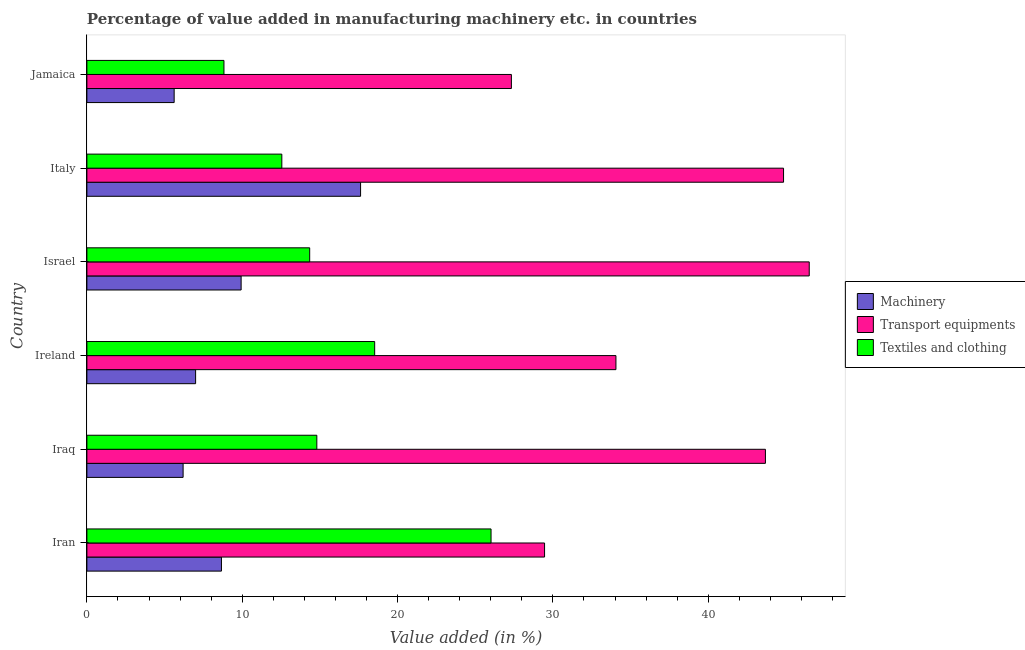How many different coloured bars are there?
Keep it short and to the point. 3. How many groups of bars are there?
Make the answer very short. 6. Are the number of bars on each tick of the Y-axis equal?
Your answer should be very brief. Yes. How many bars are there on the 1st tick from the top?
Your answer should be compact. 3. How many bars are there on the 6th tick from the bottom?
Offer a very short reply. 3. What is the label of the 4th group of bars from the top?
Your answer should be very brief. Ireland. What is the value added in manufacturing transport equipments in Ireland?
Keep it short and to the point. 34.06. Across all countries, what is the maximum value added in manufacturing transport equipments?
Keep it short and to the point. 46.5. Across all countries, what is the minimum value added in manufacturing machinery?
Give a very brief answer. 5.62. In which country was the value added in manufacturing transport equipments maximum?
Offer a terse response. Israel. In which country was the value added in manufacturing textile and clothing minimum?
Keep it short and to the point. Jamaica. What is the total value added in manufacturing transport equipments in the graph?
Your answer should be very brief. 225.88. What is the difference between the value added in manufacturing textile and clothing in Iraq and that in Ireland?
Provide a succinct answer. -3.72. What is the difference between the value added in manufacturing textile and clothing in Iran and the value added in manufacturing machinery in Ireland?
Ensure brevity in your answer.  19.02. What is the average value added in manufacturing machinery per country?
Offer a very short reply. 9.17. What is the difference between the value added in manufacturing transport equipments and value added in manufacturing machinery in Israel?
Give a very brief answer. 36.57. What is the ratio of the value added in manufacturing machinery in Iran to that in Italy?
Your answer should be compact. 0.49. Is the value added in manufacturing transport equipments in Ireland less than that in Jamaica?
Provide a short and direct response. No. Is the difference between the value added in manufacturing machinery in Iran and Italy greater than the difference between the value added in manufacturing transport equipments in Iran and Italy?
Provide a short and direct response. Yes. What is the difference between the highest and the second highest value added in manufacturing textile and clothing?
Ensure brevity in your answer.  7.49. What is the difference between the highest and the lowest value added in manufacturing transport equipments?
Ensure brevity in your answer.  19.17. What does the 1st bar from the top in Jamaica represents?
Ensure brevity in your answer.  Textiles and clothing. What does the 2nd bar from the bottom in Iran represents?
Your answer should be compact. Transport equipments. Are all the bars in the graph horizontal?
Your answer should be compact. Yes. How many countries are there in the graph?
Ensure brevity in your answer.  6. What is the difference between two consecutive major ticks on the X-axis?
Offer a terse response. 10. Are the values on the major ticks of X-axis written in scientific E-notation?
Your answer should be very brief. No. Does the graph contain any zero values?
Make the answer very short. No. Where does the legend appear in the graph?
Your response must be concise. Center right. What is the title of the graph?
Keep it short and to the point. Percentage of value added in manufacturing machinery etc. in countries. What is the label or title of the X-axis?
Offer a terse response. Value added (in %). What is the Value added (in %) of Machinery in Iran?
Provide a short and direct response. 8.66. What is the Value added (in %) of Transport equipments in Iran?
Make the answer very short. 29.46. What is the Value added (in %) in Textiles and clothing in Iran?
Ensure brevity in your answer.  26.02. What is the Value added (in %) in Machinery in Iraq?
Give a very brief answer. 6.19. What is the Value added (in %) in Transport equipments in Iraq?
Provide a succinct answer. 43.68. What is the Value added (in %) in Textiles and clothing in Iraq?
Offer a very short reply. 14.8. What is the Value added (in %) in Machinery in Ireland?
Offer a very short reply. 7. What is the Value added (in %) of Transport equipments in Ireland?
Your answer should be very brief. 34.06. What is the Value added (in %) in Textiles and clothing in Ireland?
Make the answer very short. 18.53. What is the Value added (in %) of Machinery in Israel?
Offer a very short reply. 9.93. What is the Value added (in %) in Transport equipments in Israel?
Offer a very short reply. 46.5. What is the Value added (in %) of Textiles and clothing in Israel?
Provide a succinct answer. 14.34. What is the Value added (in %) in Machinery in Italy?
Give a very brief answer. 17.62. What is the Value added (in %) of Transport equipments in Italy?
Your response must be concise. 44.85. What is the Value added (in %) in Textiles and clothing in Italy?
Make the answer very short. 12.55. What is the Value added (in %) in Machinery in Jamaica?
Keep it short and to the point. 5.62. What is the Value added (in %) in Transport equipments in Jamaica?
Keep it short and to the point. 27.33. What is the Value added (in %) in Textiles and clothing in Jamaica?
Your response must be concise. 8.82. Across all countries, what is the maximum Value added (in %) of Machinery?
Offer a terse response. 17.62. Across all countries, what is the maximum Value added (in %) in Transport equipments?
Offer a very short reply. 46.5. Across all countries, what is the maximum Value added (in %) in Textiles and clothing?
Give a very brief answer. 26.02. Across all countries, what is the minimum Value added (in %) of Machinery?
Your response must be concise. 5.62. Across all countries, what is the minimum Value added (in %) in Transport equipments?
Your answer should be compact. 27.33. Across all countries, what is the minimum Value added (in %) in Textiles and clothing?
Offer a terse response. 8.82. What is the total Value added (in %) in Machinery in the graph?
Provide a short and direct response. 55.02. What is the total Value added (in %) of Transport equipments in the graph?
Offer a very short reply. 225.88. What is the total Value added (in %) of Textiles and clothing in the graph?
Your answer should be compact. 95.06. What is the difference between the Value added (in %) in Machinery in Iran and that in Iraq?
Provide a succinct answer. 2.47. What is the difference between the Value added (in %) of Transport equipments in Iran and that in Iraq?
Offer a terse response. -14.22. What is the difference between the Value added (in %) of Textiles and clothing in Iran and that in Iraq?
Offer a very short reply. 11.22. What is the difference between the Value added (in %) in Machinery in Iran and that in Ireland?
Provide a short and direct response. 1.66. What is the difference between the Value added (in %) of Transport equipments in Iran and that in Ireland?
Give a very brief answer. -4.59. What is the difference between the Value added (in %) of Textiles and clothing in Iran and that in Ireland?
Give a very brief answer. 7.49. What is the difference between the Value added (in %) of Machinery in Iran and that in Israel?
Ensure brevity in your answer.  -1.27. What is the difference between the Value added (in %) of Transport equipments in Iran and that in Israel?
Your response must be concise. -17.04. What is the difference between the Value added (in %) of Textiles and clothing in Iran and that in Israel?
Your response must be concise. 11.68. What is the difference between the Value added (in %) in Machinery in Iran and that in Italy?
Make the answer very short. -8.96. What is the difference between the Value added (in %) of Transport equipments in Iran and that in Italy?
Your response must be concise. -15.38. What is the difference between the Value added (in %) of Textiles and clothing in Iran and that in Italy?
Ensure brevity in your answer.  13.47. What is the difference between the Value added (in %) of Machinery in Iran and that in Jamaica?
Provide a succinct answer. 3.04. What is the difference between the Value added (in %) in Transport equipments in Iran and that in Jamaica?
Your answer should be compact. 2.14. What is the difference between the Value added (in %) of Textiles and clothing in Iran and that in Jamaica?
Offer a very short reply. 17.19. What is the difference between the Value added (in %) of Machinery in Iraq and that in Ireland?
Your answer should be very brief. -0.8. What is the difference between the Value added (in %) in Transport equipments in Iraq and that in Ireland?
Keep it short and to the point. 9.62. What is the difference between the Value added (in %) of Textiles and clothing in Iraq and that in Ireland?
Offer a terse response. -3.72. What is the difference between the Value added (in %) of Machinery in Iraq and that in Israel?
Your answer should be compact. -3.73. What is the difference between the Value added (in %) of Transport equipments in Iraq and that in Israel?
Your answer should be compact. -2.82. What is the difference between the Value added (in %) of Textiles and clothing in Iraq and that in Israel?
Your response must be concise. 0.46. What is the difference between the Value added (in %) in Machinery in Iraq and that in Italy?
Offer a very short reply. -11.42. What is the difference between the Value added (in %) in Transport equipments in Iraq and that in Italy?
Make the answer very short. -1.17. What is the difference between the Value added (in %) in Textiles and clothing in Iraq and that in Italy?
Your response must be concise. 2.25. What is the difference between the Value added (in %) of Machinery in Iraq and that in Jamaica?
Offer a very short reply. 0.58. What is the difference between the Value added (in %) of Transport equipments in Iraq and that in Jamaica?
Provide a succinct answer. 16.35. What is the difference between the Value added (in %) of Textiles and clothing in Iraq and that in Jamaica?
Your response must be concise. 5.98. What is the difference between the Value added (in %) in Machinery in Ireland and that in Israel?
Your answer should be compact. -2.93. What is the difference between the Value added (in %) in Transport equipments in Ireland and that in Israel?
Give a very brief answer. -12.44. What is the difference between the Value added (in %) of Textiles and clothing in Ireland and that in Israel?
Offer a terse response. 4.18. What is the difference between the Value added (in %) of Machinery in Ireland and that in Italy?
Your response must be concise. -10.62. What is the difference between the Value added (in %) of Transport equipments in Ireland and that in Italy?
Provide a succinct answer. -10.79. What is the difference between the Value added (in %) of Textiles and clothing in Ireland and that in Italy?
Ensure brevity in your answer.  5.98. What is the difference between the Value added (in %) in Machinery in Ireland and that in Jamaica?
Provide a succinct answer. 1.38. What is the difference between the Value added (in %) in Transport equipments in Ireland and that in Jamaica?
Your response must be concise. 6.73. What is the difference between the Value added (in %) in Textiles and clothing in Ireland and that in Jamaica?
Keep it short and to the point. 9.7. What is the difference between the Value added (in %) of Machinery in Israel and that in Italy?
Offer a very short reply. -7.69. What is the difference between the Value added (in %) of Transport equipments in Israel and that in Italy?
Provide a succinct answer. 1.65. What is the difference between the Value added (in %) of Textiles and clothing in Israel and that in Italy?
Your response must be concise. 1.79. What is the difference between the Value added (in %) in Machinery in Israel and that in Jamaica?
Keep it short and to the point. 4.31. What is the difference between the Value added (in %) of Transport equipments in Israel and that in Jamaica?
Provide a short and direct response. 19.17. What is the difference between the Value added (in %) in Textiles and clothing in Israel and that in Jamaica?
Give a very brief answer. 5.52. What is the difference between the Value added (in %) in Machinery in Italy and that in Jamaica?
Offer a very short reply. 12. What is the difference between the Value added (in %) of Transport equipments in Italy and that in Jamaica?
Ensure brevity in your answer.  17.52. What is the difference between the Value added (in %) in Textiles and clothing in Italy and that in Jamaica?
Give a very brief answer. 3.73. What is the difference between the Value added (in %) in Machinery in Iran and the Value added (in %) in Transport equipments in Iraq?
Give a very brief answer. -35.02. What is the difference between the Value added (in %) of Machinery in Iran and the Value added (in %) of Textiles and clothing in Iraq?
Make the answer very short. -6.14. What is the difference between the Value added (in %) of Transport equipments in Iran and the Value added (in %) of Textiles and clothing in Iraq?
Your answer should be compact. 14.66. What is the difference between the Value added (in %) in Machinery in Iran and the Value added (in %) in Transport equipments in Ireland?
Provide a short and direct response. -25.4. What is the difference between the Value added (in %) of Machinery in Iran and the Value added (in %) of Textiles and clothing in Ireland?
Offer a terse response. -9.86. What is the difference between the Value added (in %) in Transport equipments in Iran and the Value added (in %) in Textiles and clothing in Ireland?
Offer a terse response. 10.94. What is the difference between the Value added (in %) of Machinery in Iran and the Value added (in %) of Transport equipments in Israel?
Keep it short and to the point. -37.84. What is the difference between the Value added (in %) in Machinery in Iran and the Value added (in %) in Textiles and clothing in Israel?
Provide a succinct answer. -5.68. What is the difference between the Value added (in %) of Transport equipments in Iran and the Value added (in %) of Textiles and clothing in Israel?
Offer a very short reply. 15.12. What is the difference between the Value added (in %) in Machinery in Iran and the Value added (in %) in Transport equipments in Italy?
Your response must be concise. -36.18. What is the difference between the Value added (in %) of Machinery in Iran and the Value added (in %) of Textiles and clothing in Italy?
Ensure brevity in your answer.  -3.89. What is the difference between the Value added (in %) of Transport equipments in Iran and the Value added (in %) of Textiles and clothing in Italy?
Offer a terse response. 16.91. What is the difference between the Value added (in %) in Machinery in Iran and the Value added (in %) in Transport equipments in Jamaica?
Offer a terse response. -18.66. What is the difference between the Value added (in %) of Machinery in Iran and the Value added (in %) of Textiles and clothing in Jamaica?
Your response must be concise. -0.16. What is the difference between the Value added (in %) of Transport equipments in Iran and the Value added (in %) of Textiles and clothing in Jamaica?
Offer a terse response. 20.64. What is the difference between the Value added (in %) in Machinery in Iraq and the Value added (in %) in Transport equipments in Ireland?
Your answer should be compact. -27.86. What is the difference between the Value added (in %) in Machinery in Iraq and the Value added (in %) in Textiles and clothing in Ireland?
Your answer should be compact. -12.33. What is the difference between the Value added (in %) of Transport equipments in Iraq and the Value added (in %) of Textiles and clothing in Ireland?
Provide a short and direct response. 25.16. What is the difference between the Value added (in %) of Machinery in Iraq and the Value added (in %) of Transport equipments in Israel?
Give a very brief answer. -40.31. What is the difference between the Value added (in %) in Machinery in Iraq and the Value added (in %) in Textiles and clothing in Israel?
Make the answer very short. -8.15. What is the difference between the Value added (in %) of Transport equipments in Iraq and the Value added (in %) of Textiles and clothing in Israel?
Offer a terse response. 29.34. What is the difference between the Value added (in %) in Machinery in Iraq and the Value added (in %) in Transport equipments in Italy?
Offer a very short reply. -38.65. What is the difference between the Value added (in %) of Machinery in Iraq and the Value added (in %) of Textiles and clothing in Italy?
Make the answer very short. -6.36. What is the difference between the Value added (in %) of Transport equipments in Iraq and the Value added (in %) of Textiles and clothing in Italy?
Keep it short and to the point. 31.13. What is the difference between the Value added (in %) of Machinery in Iraq and the Value added (in %) of Transport equipments in Jamaica?
Provide a succinct answer. -21.13. What is the difference between the Value added (in %) in Machinery in Iraq and the Value added (in %) in Textiles and clothing in Jamaica?
Offer a terse response. -2.63. What is the difference between the Value added (in %) of Transport equipments in Iraq and the Value added (in %) of Textiles and clothing in Jamaica?
Ensure brevity in your answer.  34.86. What is the difference between the Value added (in %) in Machinery in Ireland and the Value added (in %) in Transport equipments in Israel?
Your response must be concise. -39.5. What is the difference between the Value added (in %) of Machinery in Ireland and the Value added (in %) of Textiles and clothing in Israel?
Your response must be concise. -7.34. What is the difference between the Value added (in %) of Transport equipments in Ireland and the Value added (in %) of Textiles and clothing in Israel?
Give a very brief answer. 19.72. What is the difference between the Value added (in %) in Machinery in Ireland and the Value added (in %) in Transport equipments in Italy?
Your answer should be very brief. -37.85. What is the difference between the Value added (in %) in Machinery in Ireland and the Value added (in %) in Textiles and clothing in Italy?
Keep it short and to the point. -5.55. What is the difference between the Value added (in %) in Transport equipments in Ireland and the Value added (in %) in Textiles and clothing in Italy?
Offer a terse response. 21.51. What is the difference between the Value added (in %) in Machinery in Ireland and the Value added (in %) in Transport equipments in Jamaica?
Offer a terse response. -20.33. What is the difference between the Value added (in %) of Machinery in Ireland and the Value added (in %) of Textiles and clothing in Jamaica?
Your answer should be compact. -1.83. What is the difference between the Value added (in %) of Transport equipments in Ireland and the Value added (in %) of Textiles and clothing in Jamaica?
Your response must be concise. 25.23. What is the difference between the Value added (in %) of Machinery in Israel and the Value added (in %) of Transport equipments in Italy?
Offer a very short reply. -34.92. What is the difference between the Value added (in %) of Machinery in Israel and the Value added (in %) of Textiles and clothing in Italy?
Your answer should be very brief. -2.62. What is the difference between the Value added (in %) in Transport equipments in Israel and the Value added (in %) in Textiles and clothing in Italy?
Provide a succinct answer. 33.95. What is the difference between the Value added (in %) in Machinery in Israel and the Value added (in %) in Transport equipments in Jamaica?
Offer a terse response. -17.4. What is the difference between the Value added (in %) in Machinery in Israel and the Value added (in %) in Textiles and clothing in Jamaica?
Give a very brief answer. 1.11. What is the difference between the Value added (in %) in Transport equipments in Israel and the Value added (in %) in Textiles and clothing in Jamaica?
Your answer should be compact. 37.68. What is the difference between the Value added (in %) in Machinery in Italy and the Value added (in %) in Transport equipments in Jamaica?
Make the answer very short. -9.71. What is the difference between the Value added (in %) of Machinery in Italy and the Value added (in %) of Textiles and clothing in Jamaica?
Offer a terse response. 8.8. What is the difference between the Value added (in %) of Transport equipments in Italy and the Value added (in %) of Textiles and clothing in Jamaica?
Provide a short and direct response. 36.02. What is the average Value added (in %) of Machinery per country?
Offer a terse response. 9.17. What is the average Value added (in %) in Transport equipments per country?
Offer a very short reply. 37.65. What is the average Value added (in %) in Textiles and clothing per country?
Provide a short and direct response. 15.84. What is the difference between the Value added (in %) of Machinery and Value added (in %) of Transport equipments in Iran?
Your answer should be compact. -20.8. What is the difference between the Value added (in %) in Machinery and Value added (in %) in Textiles and clothing in Iran?
Your answer should be very brief. -17.36. What is the difference between the Value added (in %) of Transport equipments and Value added (in %) of Textiles and clothing in Iran?
Provide a short and direct response. 3.44. What is the difference between the Value added (in %) in Machinery and Value added (in %) in Transport equipments in Iraq?
Your answer should be very brief. -37.49. What is the difference between the Value added (in %) in Machinery and Value added (in %) in Textiles and clothing in Iraq?
Give a very brief answer. -8.61. What is the difference between the Value added (in %) of Transport equipments and Value added (in %) of Textiles and clothing in Iraq?
Your response must be concise. 28.88. What is the difference between the Value added (in %) of Machinery and Value added (in %) of Transport equipments in Ireland?
Your answer should be compact. -27.06. What is the difference between the Value added (in %) of Machinery and Value added (in %) of Textiles and clothing in Ireland?
Your answer should be very brief. -11.53. What is the difference between the Value added (in %) in Transport equipments and Value added (in %) in Textiles and clothing in Ireland?
Provide a short and direct response. 15.53. What is the difference between the Value added (in %) of Machinery and Value added (in %) of Transport equipments in Israel?
Your answer should be very brief. -36.57. What is the difference between the Value added (in %) of Machinery and Value added (in %) of Textiles and clothing in Israel?
Provide a short and direct response. -4.41. What is the difference between the Value added (in %) in Transport equipments and Value added (in %) in Textiles and clothing in Israel?
Offer a very short reply. 32.16. What is the difference between the Value added (in %) in Machinery and Value added (in %) in Transport equipments in Italy?
Give a very brief answer. -27.23. What is the difference between the Value added (in %) of Machinery and Value added (in %) of Textiles and clothing in Italy?
Your answer should be very brief. 5.07. What is the difference between the Value added (in %) of Transport equipments and Value added (in %) of Textiles and clothing in Italy?
Your response must be concise. 32.3. What is the difference between the Value added (in %) of Machinery and Value added (in %) of Transport equipments in Jamaica?
Give a very brief answer. -21.71. What is the difference between the Value added (in %) in Machinery and Value added (in %) in Textiles and clothing in Jamaica?
Make the answer very short. -3.21. What is the difference between the Value added (in %) in Transport equipments and Value added (in %) in Textiles and clothing in Jamaica?
Provide a short and direct response. 18.5. What is the ratio of the Value added (in %) in Machinery in Iran to that in Iraq?
Keep it short and to the point. 1.4. What is the ratio of the Value added (in %) of Transport equipments in Iran to that in Iraq?
Make the answer very short. 0.67. What is the ratio of the Value added (in %) of Textiles and clothing in Iran to that in Iraq?
Your answer should be very brief. 1.76. What is the ratio of the Value added (in %) of Machinery in Iran to that in Ireland?
Your answer should be compact. 1.24. What is the ratio of the Value added (in %) in Transport equipments in Iran to that in Ireland?
Make the answer very short. 0.87. What is the ratio of the Value added (in %) of Textiles and clothing in Iran to that in Ireland?
Keep it short and to the point. 1.4. What is the ratio of the Value added (in %) of Machinery in Iran to that in Israel?
Offer a terse response. 0.87. What is the ratio of the Value added (in %) of Transport equipments in Iran to that in Israel?
Your response must be concise. 0.63. What is the ratio of the Value added (in %) in Textiles and clothing in Iran to that in Israel?
Offer a terse response. 1.81. What is the ratio of the Value added (in %) in Machinery in Iran to that in Italy?
Offer a terse response. 0.49. What is the ratio of the Value added (in %) of Transport equipments in Iran to that in Italy?
Provide a succinct answer. 0.66. What is the ratio of the Value added (in %) of Textiles and clothing in Iran to that in Italy?
Offer a terse response. 2.07. What is the ratio of the Value added (in %) in Machinery in Iran to that in Jamaica?
Your answer should be very brief. 1.54. What is the ratio of the Value added (in %) in Transport equipments in Iran to that in Jamaica?
Offer a terse response. 1.08. What is the ratio of the Value added (in %) in Textiles and clothing in Iran to that in Jamaica?
Your response must be concise. 2.95. What is the ratio of the Value added (in %) of Machinery in Iraq to that in Ireland?
Ensure brevity in your answer.  0.89. What is the ratio of the Value added (in %) of Transport equipments in Iraq to that in Ireland?
Offer a very short reply. 1.28. What is the ratio of the Value added (in %) in Textiles and clothing in Iraq to that in Ireland?
Offer a terse response. 0.8. What is the ratio of the Value added (in %) of Machinery in Iraq to that in Israel?
Offer a very short reply. 0.62. What is the ratio of the Value added (in %) of Transport equipments in Iraq to that in Israel?
Provide a short and direct response. 0.94. What is the ratio of the Value added (in %) in Textiles and clothing in Iraq to that in Israel?
Your response must be concise. 1.03. What is the ratio of the Value added (in %) of Machinery in Iraq to that in Italy?
Keep it short and to the point. 0.35. What is the ratio of the Value added (in %) of Textiles and clothing in Iraq to that in Italy?
Your answer should be very brief. 1.18. What is the ratio of the Value added (in %) of Machinery in Iraq to that in Jamaica?
Offer a very short reply. 1.1. What is the ratio of the Value added (in %) in Transport equipments in Iraq to that in Jamaica?
Give a very brief answer. 1.6. What is the ratio of the Value added (in %) of Textiles and clothing in Iraq to that in Jamaica?
Offer a terse response. 1.68. What is the ratio of the Value added (in %) in Machinery in Ireland to that in Israel?
Your answer should be very brief. 0.7. What is the ratio of the Value added (in %) in Transport equipments in Ireland to that in Israel?
Make the answer very short. 0.73. What is the ratio of the Value added (in %) of Textiles and clothing in Ireland to that in Israel?
Provide a succinct answer. 1.29. What is the ratio of the Value added (in %) in Machinery in Ireland to that in Italy?
Your answer should be very brief. 0.4. What is the ratio of the Value added (in %) of Transport equipments in Ireland to that in Italy?
Offer a terse response. 0.76. What is the ratio of the Value added (in %) of Textiles and clothing in Ireland to that in Italy?
Your answer should be very brief. 1.48. What is the ratio of the Value added (in %) in Machinery in Ireland to that in Jamaica?
Ensure brevity in your answer.  1.25. What is the ratio of the Value added (in %) of Transport equipments in Ireland to that in Jamaica?
Provide a short and direct response. 1.25. What is the ratio of the Value added (in %) in Textiles and clothing in Ireland to that in Jamaica?
Ensure brevity in your answer.  2.1. What is the ratio of the Value added (in %) in Machinery in Israel to that in Italy?
Give a very brief answer. 0.56. What is the ratio of the Value added (in %) of Transport equipments in Israel to that in Italy?
Provide a short and direct response. 1.04. What is the ratio of the Value added (in %) of Textiles and clothing in Israel to that in Italy?
Provide a short and direct response. 1.14. What is the ratio of the Value added (in %) of Machinery in Israel to that in Jamaica?
Your response must be concise. 1.77. What is the ratio of the Value added (in %) in Transport equipments in Israel to that in Jamaica?
Offer a terse response. 1.7. What is the ratio of the Value added (in %) of Textiles and clothing in Israel to that in Jamaica?
Your answer should be compact. 1.63. What is the ratio of the Value added (in %) in Machinery in Italy to that in Jamaica?
Your answer should be compact. 3.14. What is the ratio of the Value added (in %) in Transport equipments in Italy to that in Jamaica?
Offer a very short reply. 1.64. What is the ratio of the Value added (in %) of Textiles and clothing in Italy to that in Jamaica?
Offer a very short reply. 1.42. What is the difference between the highest and the second highest Value added (in %) in Machinery?
Ensure brevity in your answer.  7.69. What is the difference between the highest and the second highest Value added (in %) of Transport equipments?
Give a very brief answer. 1.65. What is the difference between the highest and the second highest Value added (in %) of Textiles and clothing?
Make the answer very short. 7.49. What is the difference between the highest and the lowest Value added (in %) in Machinery?
Make the answer very short. 12. What is the difference between the highest and the lowest Value added (in %) of Transport equipments?
Keep it short and to the point. 19.17. What is the difference between the highest and the lowest Value added (in %) in Textiles and clothing?
Provide a succinct answer. 17.19. 